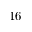<formula> <loc_0><loc_0><loc_500><loc_500>1 6</formula> 